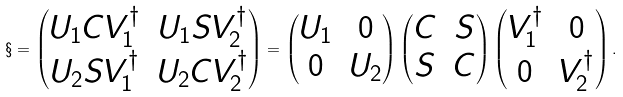Convert formula to latex. <formula><loc_0><loc_0><loc_500><loc_500>\S = \begin{pmatrix} U _ { 1 } C V _ { 1 } ^ { \dagger } & U _ { 1 } S V _ { 2 } ^ { \dagger } \\ U _ { 2 } S V _ { 1 } ^ { \dagger } & U _ { 2 } C V _ { 2 } ^ { \dagger } \end{pmatrix} = \begin{pmatrix} U _ { 1 } & 0 \\ 0 & U _ { 2 } \end{pmatrix} \begin{pmatrix} C & S \\ S & C \end{pmatrix} \begin{pmatrix} V _ { 1 } ^ { \dagger } & 0 \\ 0 & V _ { 2 } ^ { \dagger } \end{pmatrix} .</formula> 